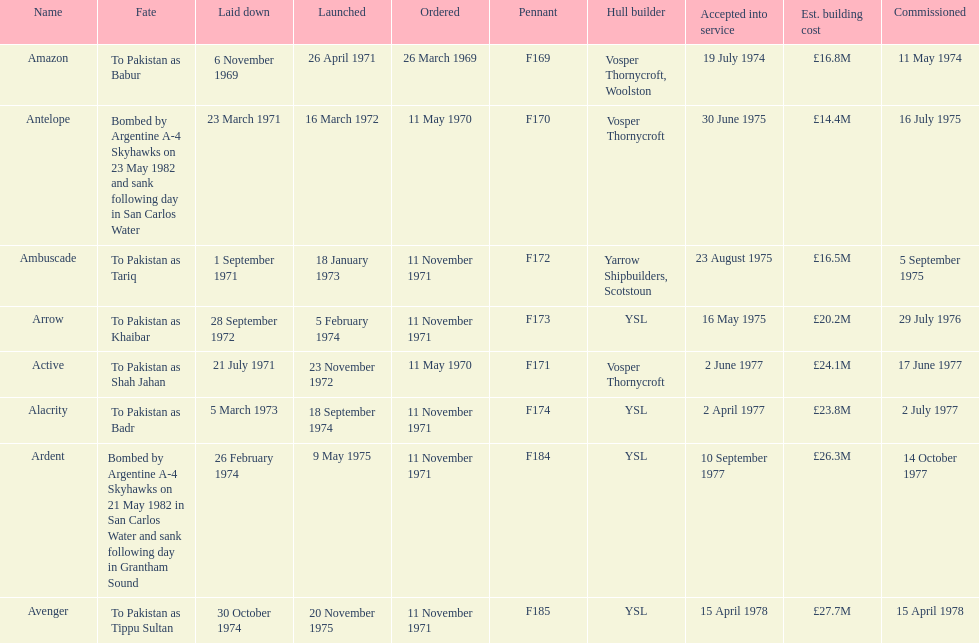Can you provide the quantity of ships that journeyed to pakistan? 6. Could you parse the entire table? {'header': ['Name', 'Fate', 'Laid down', 'Launched', 'Ordered', 'Pennant', 'Hull builder', 'Accepted into service', 'Est. building cost', 'Commissioned'], 'rows': [['Amazon', 'To Pakistan as Babur', '6 November 1969', '26 April 1971', '26 March 1969', 'F169', 'Vosper Thornycroft, Woolston', '19 July 1974', '£16.8M', '11 May 1974'], ['Antelope', 'Bombed by Argentine A-4 Skyhawks on 23 May 1982 and sank following day in San Carlos Water', '23 March 1971', '16 March 1972', '11 May 1970', 'F170', 'Vosper Thornycroft', '30 June 1975', '£14.4M', '16 July 1975'], ['Ambuscade', 'To Pakistan as Tariq', '1 September 1971', '18 January 1973', '11 November 1971', 'F172', 'Yarrow Shipbuilders, Scotstoun', '23 August 1975', '£16.5M', '5 September 1975'], ['Arrow', 'To Pakistan as Khaibar', '28 September 1972', '5 February 1974', '11 November 1971', 'F173', 'YSL', '16 May 1975', '£20.2M', '29 July 1976'], ['Active', 'To Pakistan as Shah Jahan', '21 July 1971', '23 November 1972', '11 May 1970', 'F171', 'Vosper Thornycroft', '2 June 1977', '£24.1M', '17 June 1977'], ['Alacrity', 'To Pakistan as Badr', '5 March 1973', '18 September 1974', '11 November 1971', 'F174', 'YSL', '2 April 1977', '£23.8M', '2 July 1977'], ['Ardent', 'Bombed by Argentine A-4 Skyhawks on 21 May 1982 in San Carlos Water and sank following day in Grantham Sound', '26 February 1974', '9 May 1975', '11 November 1971', 'F184', 'YSL', '10 September 1977', '£26.3M', '14 October 1977'], ['Avenger', 'To Pakistan as Tippu Sultan', '30 October 1974', '20 November 1975', '11 November 1971', 'F185', 'YSL', '15 April 1978', '£27.7M', '15 April 1978']]} 